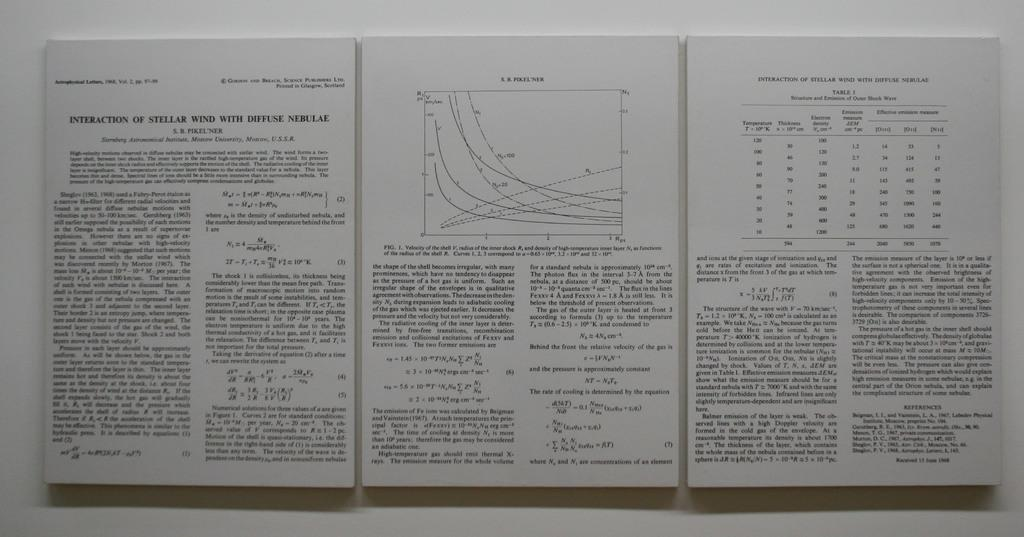What is on the wall in the image? There are posters on the wall in the image. What can be found on the posters? The posters have text on them. Can you touch the metal window in the image? There is no metal window present in the image; it only features posters on the wall. 